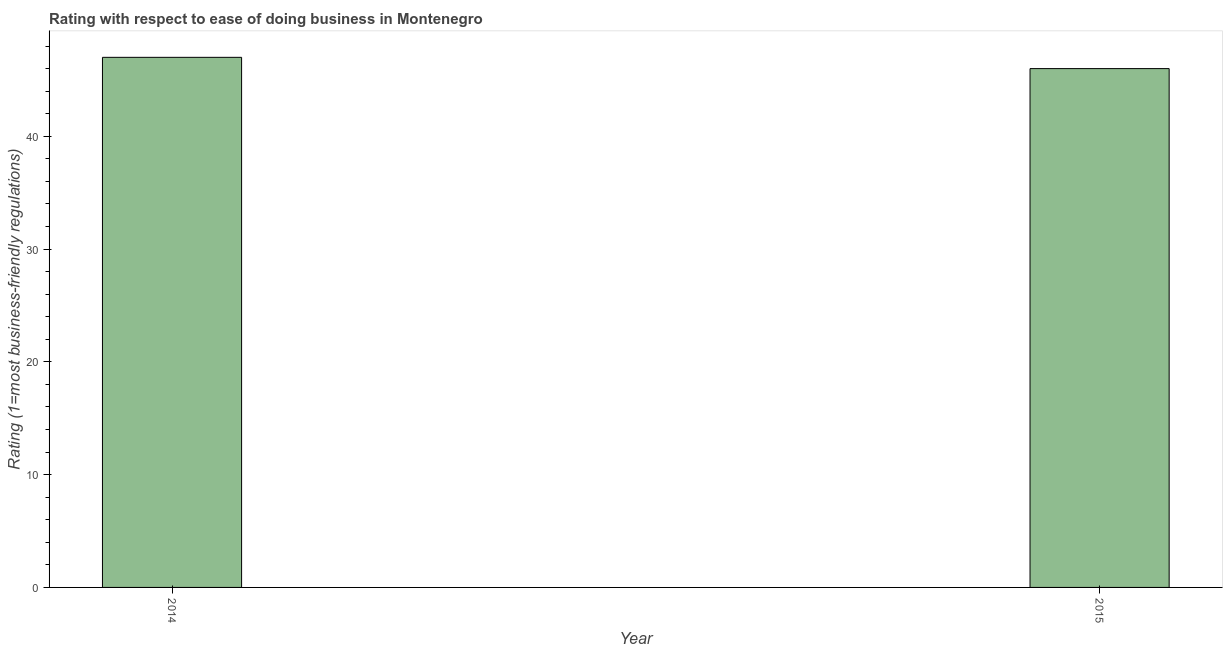Does the graph contain any zero values?
Provide a succinct answer. No. What is the title of the graph?
Make the answer very short. Rating with respect to ease of doing business in Montenegro. What is the label or title of the Y-axis?
Offer a terse response. Rating (1=most business-friendly regulations). What is the ease of doing business index in 2014?
Ensure brevity in your answer.  47. Across all years, what is the maximum ease of doing business index?
Your response must be concise. 47. Across all years, what is the minimum ease of doing business index?
Your answer should be very brief. 46. In which year was the ease of doing business index maximum?
Provide a short and direct response. 2014. In which year was the ease of doing business index minimum?
Provide a succinct answer. 2015. What is the sum of the ease of doing business index?
Your answer should be compact. 93. What is the difference between the ease of doing business index in 2014 and 2015?
Your answer should be very brief. 1. What is the median ease of doing business index?
Your response must be concise. 46.5. Is the ease of doing business index in 2014 less than that in 2015?
Keep it short and to the point. No. Are all the bars in the graph horizontal?
Your answer should be very brief. No. Are the values on the major ticks of Y-axis written in scientific E-notation?
Ensure brevity in your answer.  No. What is the Rating (1=most business-friendly regulations) in 2014?
Offer a very short reply. 47. 